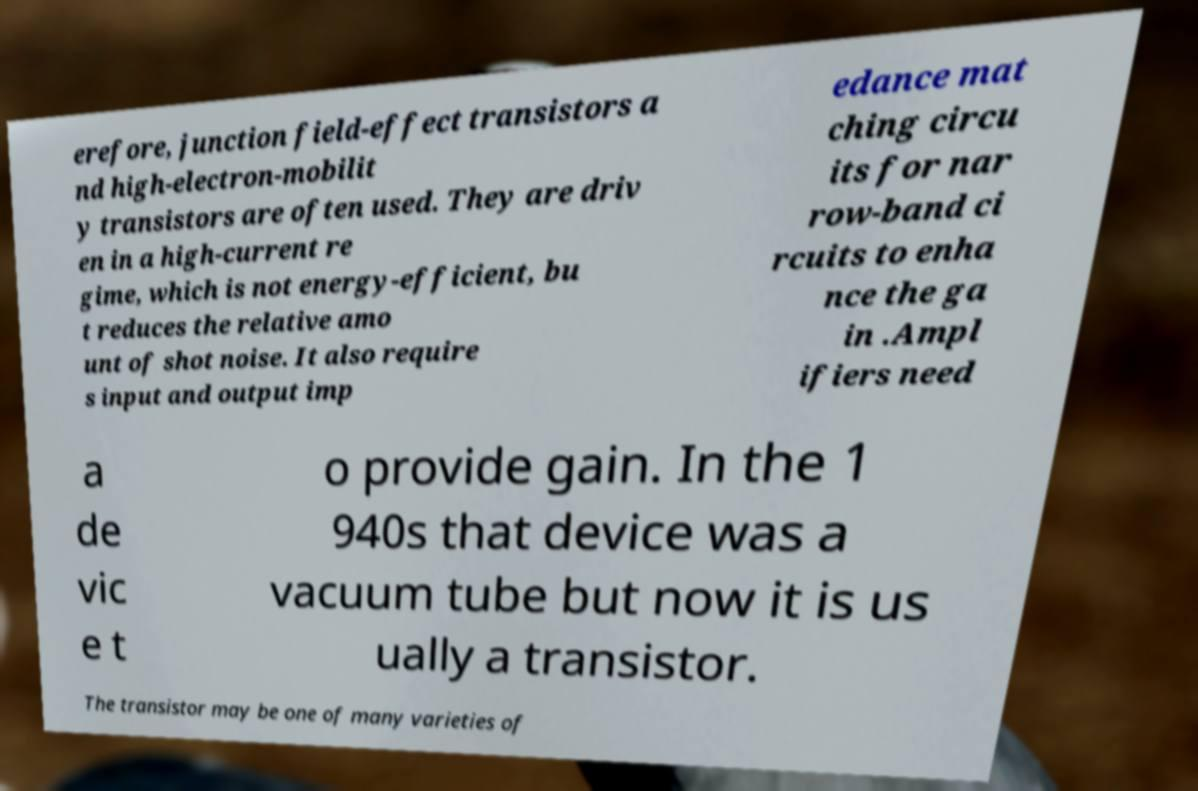What messages or text are displayed in this image? I need them in a readable, typed format. erefore, junction field-effect transistors a nd high-electron-mobilit y transistors are often used. They are driv en in a high-current re gime, which is not energy-efficient, bu t reduces the relative amo unt of shot noise. It also require s input and output imp edance mat ching circu its for nar row-band ci rcuits to enha nce the ga in .Ampl ifiers need a de vic e t o provide gain. In the 1 940s that device was a vacuum tube but now it is us ually a transistor. The transistor may be one of many varieties of 